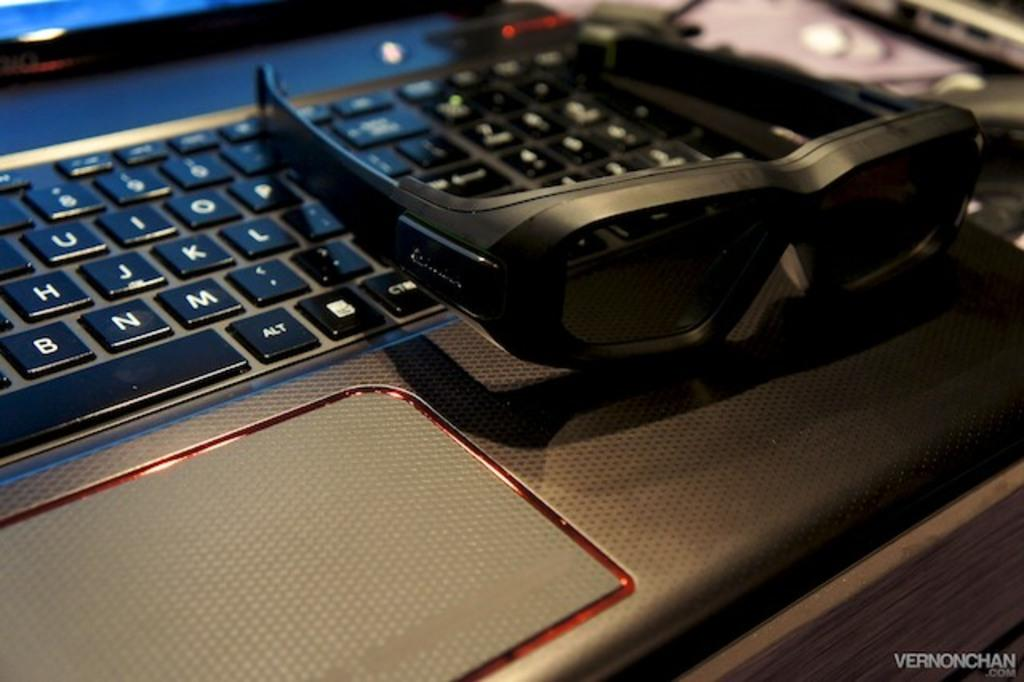<image>
Render a clear and concise summary of the photo. Black glasses sit on a laptop keyboard just to the right of the L key. 